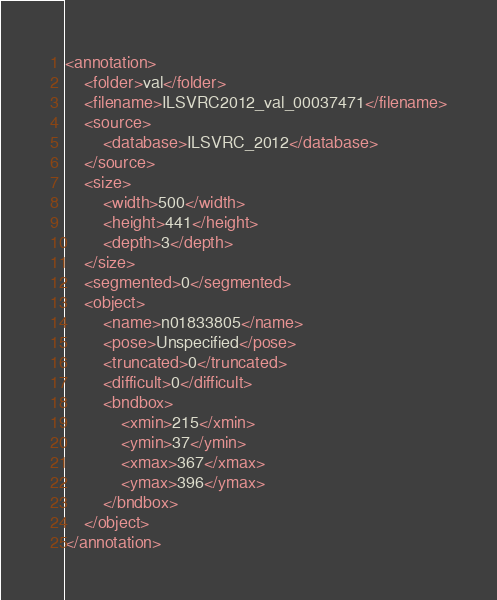<code> <loc_0><loc_0><loc_500><loc_500><_XML_><annotation>
	<folder>val</folder>
	<filename>ILSVRC2012_val_00037471</filename>
	<source>
		<database>ILSVRC_2012</database>
	</source>
	<size>
		<width>500</width>
		<height>441</height>
		<depth>3</depth>
	</size>
	<segmented>0</segmented>
	<object>
		<name>n01833805</name>
		<pose>Unspecified</pose>
		<truncated>0</truncated>
		<difficult>0</difficult>
		<bndbox>
			<xmin>215</xmin>
			<ymin>37</ymin>
			<xmax>367</xmax>
			<ymax>396</ymax>
		</bndbox>
	</object>
</annotation></code> 